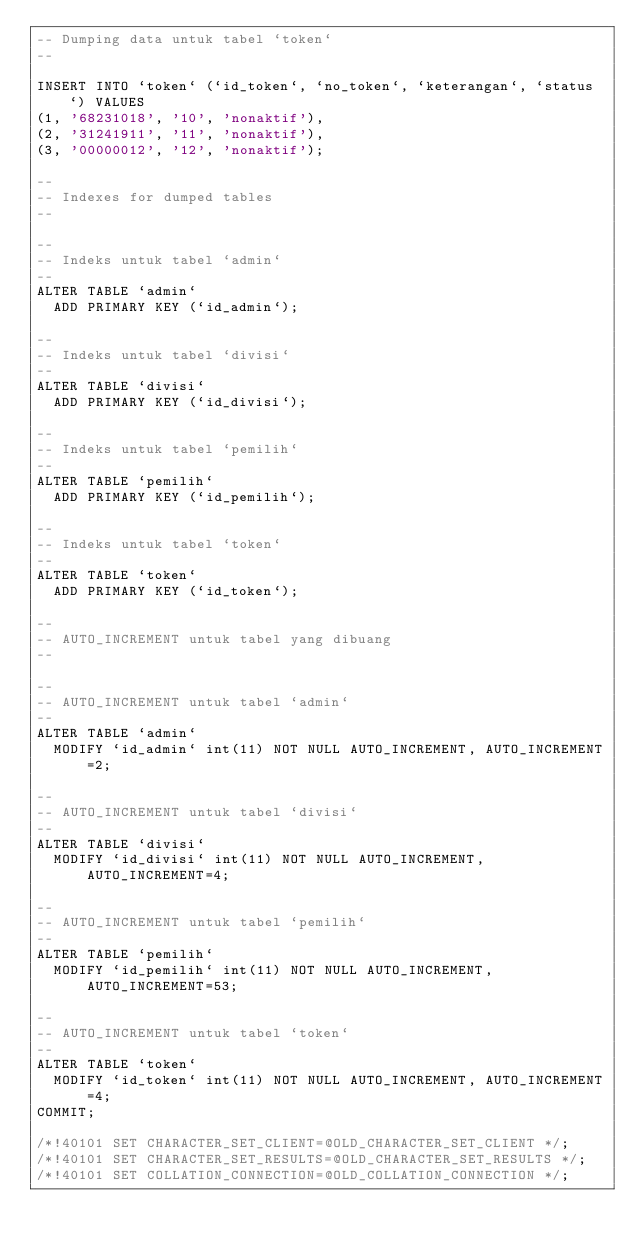<code> <loc_0><loc_0><loc_500><loc_500><_SQL_>-- Dumping data untuk tabel `token`
--

INSERT INTO `token` (`id_token`, `no_token`, `keterangan`, `status`) VALUES
(1, '68231018', '10', 'nonaktif'),
(2, '31241911', '11', 'nonaktif'),
(3, '00000012', '12', 'nonaktif');

--
-- Indexes for dumped tables
--

--
-- Indeks untuk tabel `admin`
--
ALTER TABLE `admin`
  ADD PRIMARY KEY (`id_admin`);

--
-- Indeks untuk tabel `divisi`
--
ALTER TABLE `divisi`
  ADD PRIMARY KEY (`id_divisi`);

--
-- Indeks untuk tabel `pemilih`
--
ALTER TABLE `pemilih`
  ADD PRIMARY KEY (`id_pemilih`);

--
-- Indeks untuk tabel `token`
--
ALTER TABLE `token`
  ADD PRIMARY KEY (`id_token`);

--
-- AUTO_INCREMENT untuk tabel yang dibuang
--

--
-- AUTO_INCREMENT untuk tabel `admin`
--
ALTER TABLE `admin`
  MODIFY `id_admin` int(11) NOT NULL AUTO_INCREMENT, AUTO_INCREMENT=2;

--
-- AUTO_INCREMENT untuk tabel `divisi`
--
ALTER TABLE `divisi`
  MODIFY `id_divisi` int(11) NOT NULL AUTO_INCREMENT, AUTO_INCREMENT=4;

--
-- AUTO_INCREMENT untuk tabel `pemilih`
--
ALTER TABLE `pemilih`
  MODIFY `id_pemilih` int(11) NOT NULL AUTO_INCREMENT, AUTO_INCREMENT=53;

--
-- AUTO_INCREMENT untuk tabel `token`
--
ALTER TABLE `token`
  MODIFY `id_token` int(11) NOT NULL AUTO_INCREMENT, AUTO_INCREMENT=4;
COMMIT;

/*!40101 SET CHARACTER_SET_CLIENT=@OLD_CHARACTER_SET_CLIENT */;
/*!40101 SET CHARACTER_SET_RESULTS=@OLD_CHARACTER_SET_RESULTS */;
/*!40101 SET COLLATION_CONNECTION=@OLD_COLLATION_CONNECTION */;
</code> 